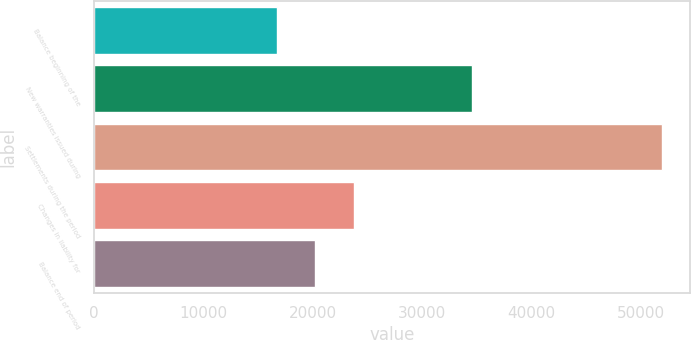Convert chart to OTSL. <chart><loc_0><loc_0><loc_500><loc_500><bar_chart><fcel>Balance beginning of the<fcel>New warranties issued during<fcel>Settlements during the period<fcel>Changes in liability for<fcel>Balance end of period<nl><fcel>16730<fcel>34574<fcel>51935<fcel>23771<fcel>20250.5<nl></chart> 